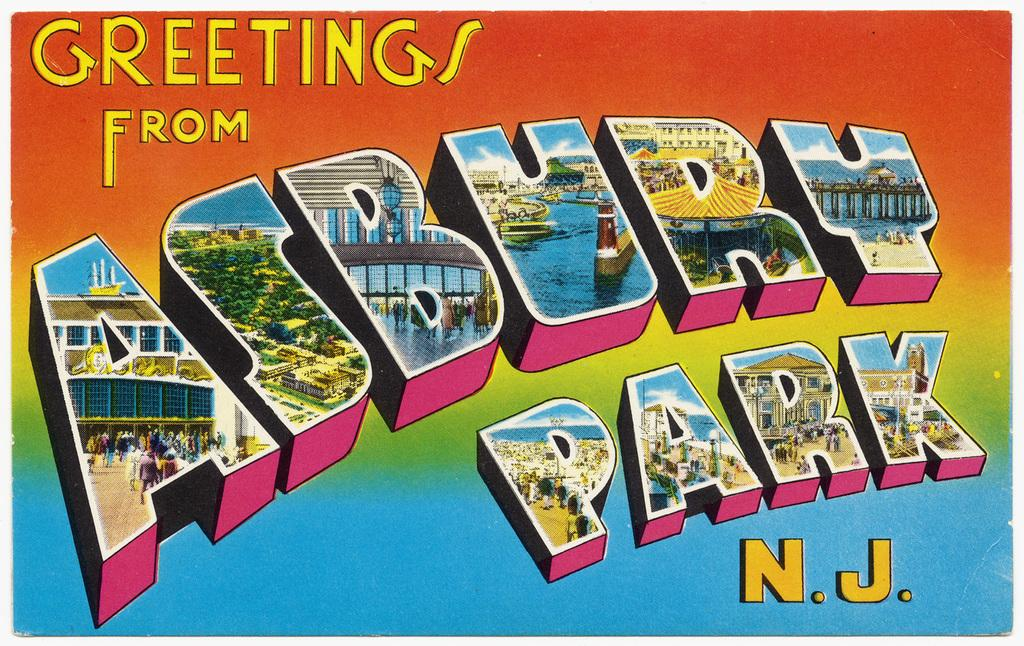<image>
Present a compact description of the photo's key features. a colorful postcard reading Greetings From Asbury Park NJ 